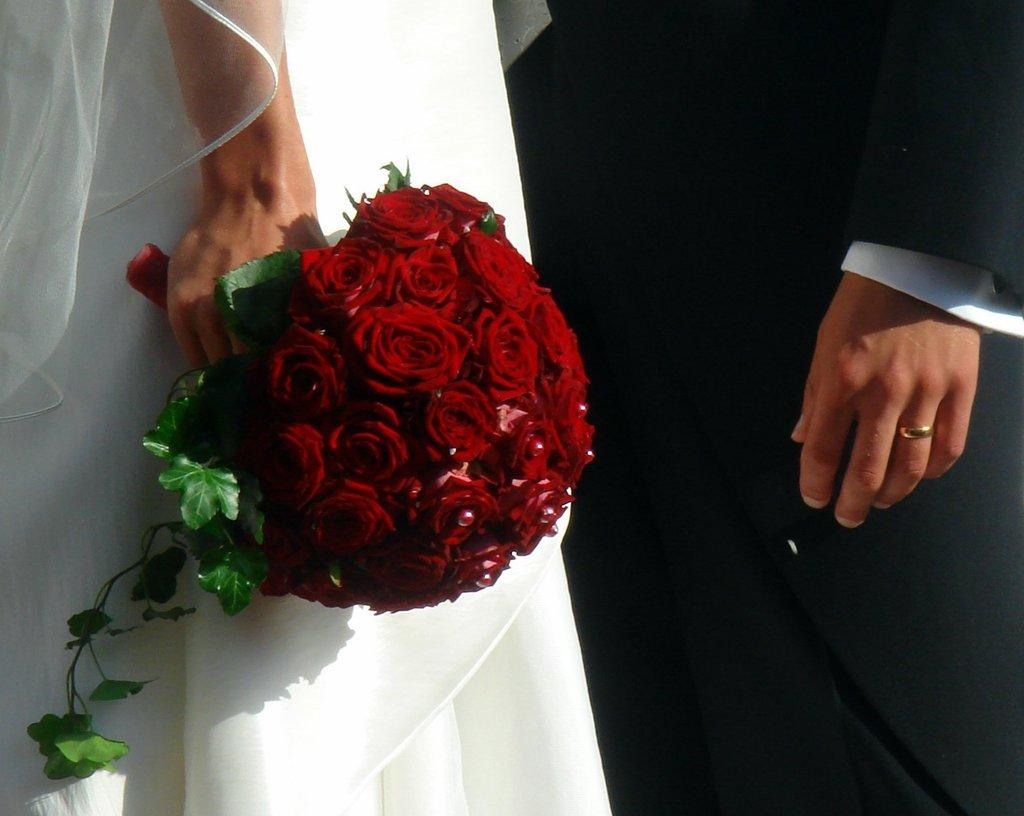What is the relationship between the two people in the image? The image features a couple, which suggests they are in a romantic relationship. What is the person on the left wearing? The person on the left is wearing a white gown and veil. What is the person on the left holding? The person on the left is holding a red rose bouquet. What is the person on the right wearing? The person on the right is wearing a black suit. How many pears are visible on the bridge in the image? There are no pears or bridges present in the image; it features a couple dressed for a special occasion. What is the tax rate for the event in the image? There is no information about tax rates in the image, as it focuses on the couple and their attire. 